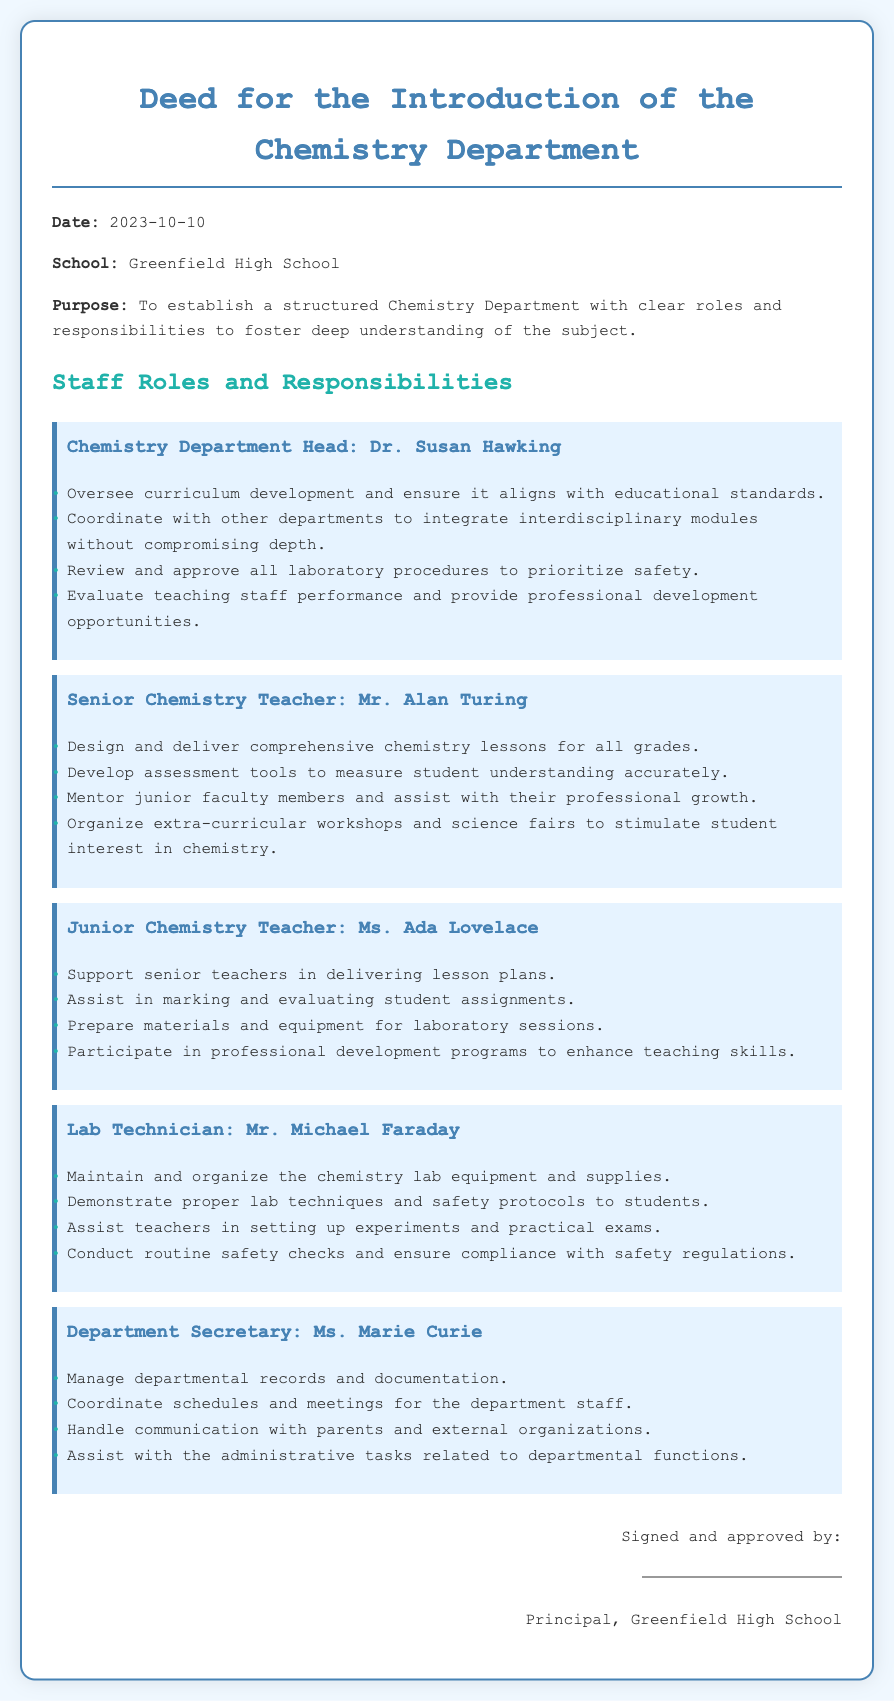What is the date of the deed? The deed is dated as specified in the document, which indicates when it was established.
Answer: 2023-10-10 Who is the Chemistry Department Head? The document lists the person in charge of the Chemistry Department, highlighting their leadership role.
Answer: Dr. Susan Hawking What is one responsibility of the Junior Chemistry Teacher? This refers to the specific tasks assigned to the Junior Chemistry Teacher as detailed in the document.
Answer: Support senior teachers in delivering lesson plans Who is the Lab Technician? The name of the individual responsible for lab maintenance and support is provided in the staff roles section.
Answer: Mr. Michael Faraday What role does the Department Secretary fulfill? The document describes the administrative functions provided by the Department Secretary.
Answer: Manage departmental records and documentation What color is used for the document's background? The document's style and design indicate the color scheme used throughout the presentation of the content.
Answer: #f0f8ff How many staff roles are defined in the document? The total number of distinct staff positions is specified within the various sections of the document.
Answer: Five What should the Chemistry Department align with? This indicates the standard frameworks that the Chemistry Department aims to adhere to according to the document.
Answer: Educational standards What type of document is this? This question refers to the categorized format in which the contents are organized, indicating its purpose.
Answer: Deed 